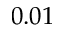Convert formula to latex. <formula><loc_0><loc_0><loc_500><loc_500>0 . 0 1</formula> 